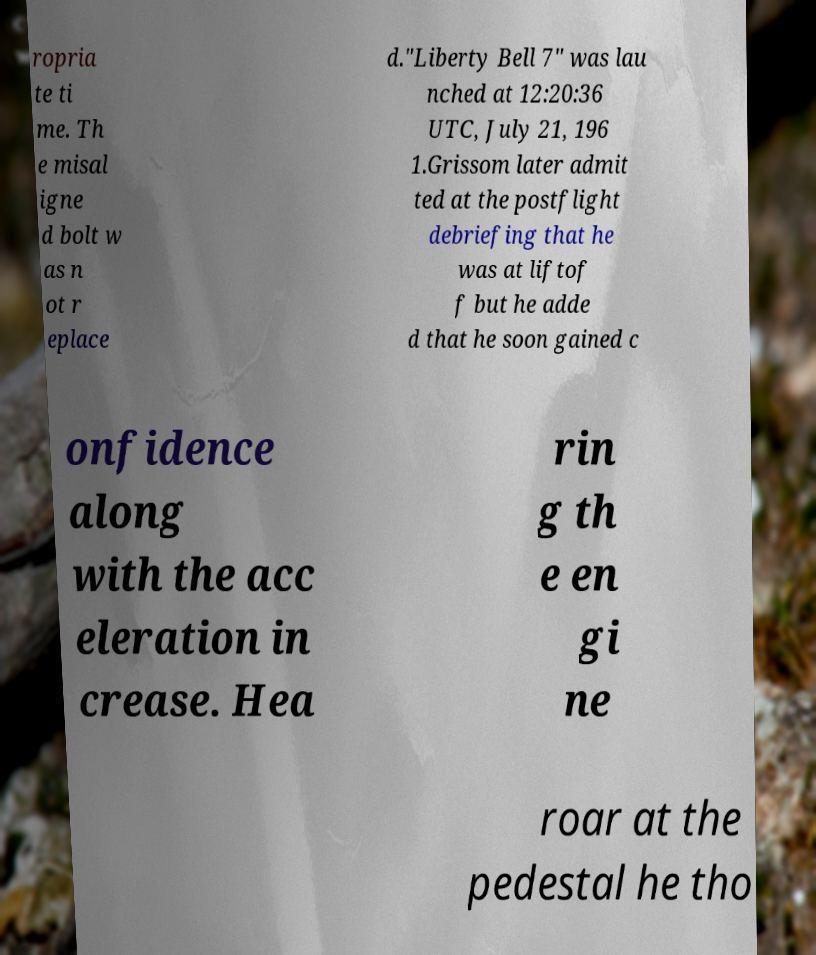Could you extract and type out the text from this image? ropria te ti me. Th e misal igne d bolt w as n ot r eplace d."Liberty Bell 7" was lau nched at 12:20:36 UTC, July 21, 196 1.Grissom later admit ted at the postflight debriefing that he was at liftof f but he adde d that he soon gained c onfidence along with the acc eleration in crease. Hea rin g th e en gi ne roar at the pedestal he tho 